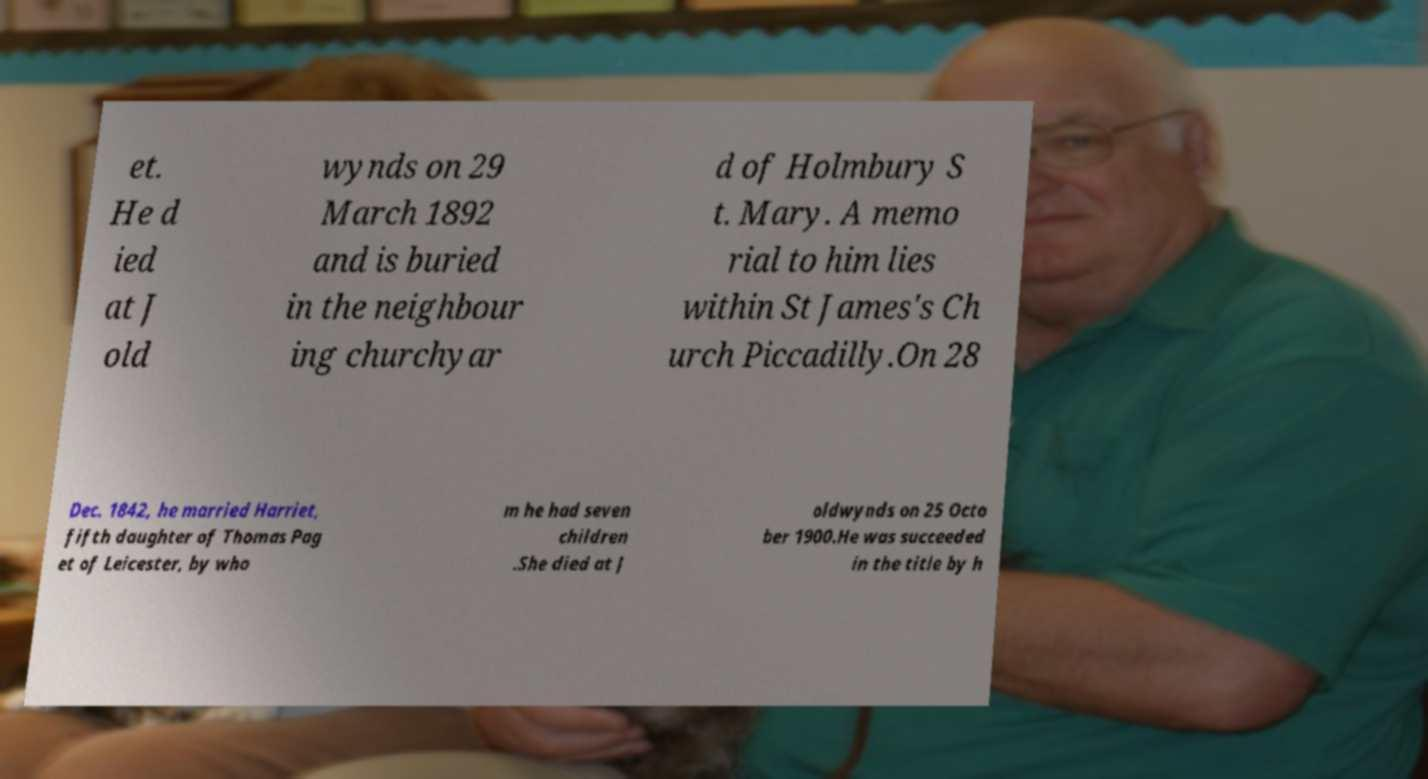There's text embedded in this image that I need extracted. Can you transcribe it verbatim? et. He d ied at J old wynds on 29 March 1892 and is buried in the neighbour ing churchyar d of Holmbury S t. Mary. A memo rial to him lies within St James's Ch urch Piccadilly.On 28 Dec. 1842, he married Harriet, fifth daughter of Thomas Pag et of Leicester, by who m he had seven children .She died at J oldwynds on 25 Octo ber 1900.He was succeeded in the title by h 